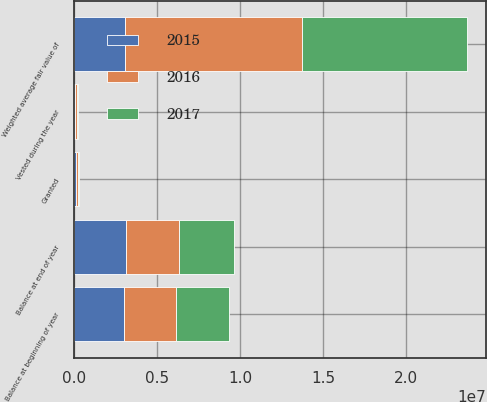<chart> <loc_0><loc_0><loc_500><loc_500><stacked_bar_chart><ecel><fcel>Balance at beginning of year<fcel>Granted<fcel>Balance at end of year<fcel>Vested during the year<fcel>Weighted average fair value of<nl><fcel>2017<fcel>3.20203e+06<fcel>96185<fcel>3.29822e+06<fcel>95736<fcel>9.90599e+06<nl><fcel>2016<fcel>3.13788e+06<fcel>98800<fcel>3.20203e+06<fcel>83822<fcel>1.06501e+07<nl><fcel>2015<fcel>3.00098e+06<fcel>143053<fcel>3.13788e+06<fcel>87081<fcel>3.06943e+06<nl></chart> 